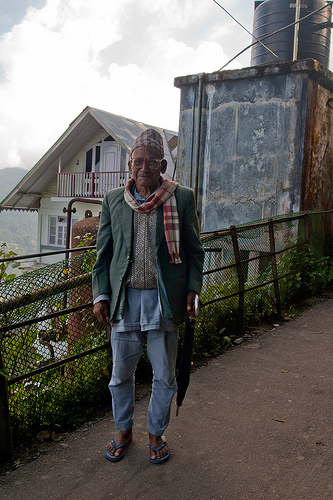<image>
Can you confirm if the fence is behind the man? Yes. From this viewpoint, the fence is positioned behind the man, with the man partially or fully occluding the fence. 